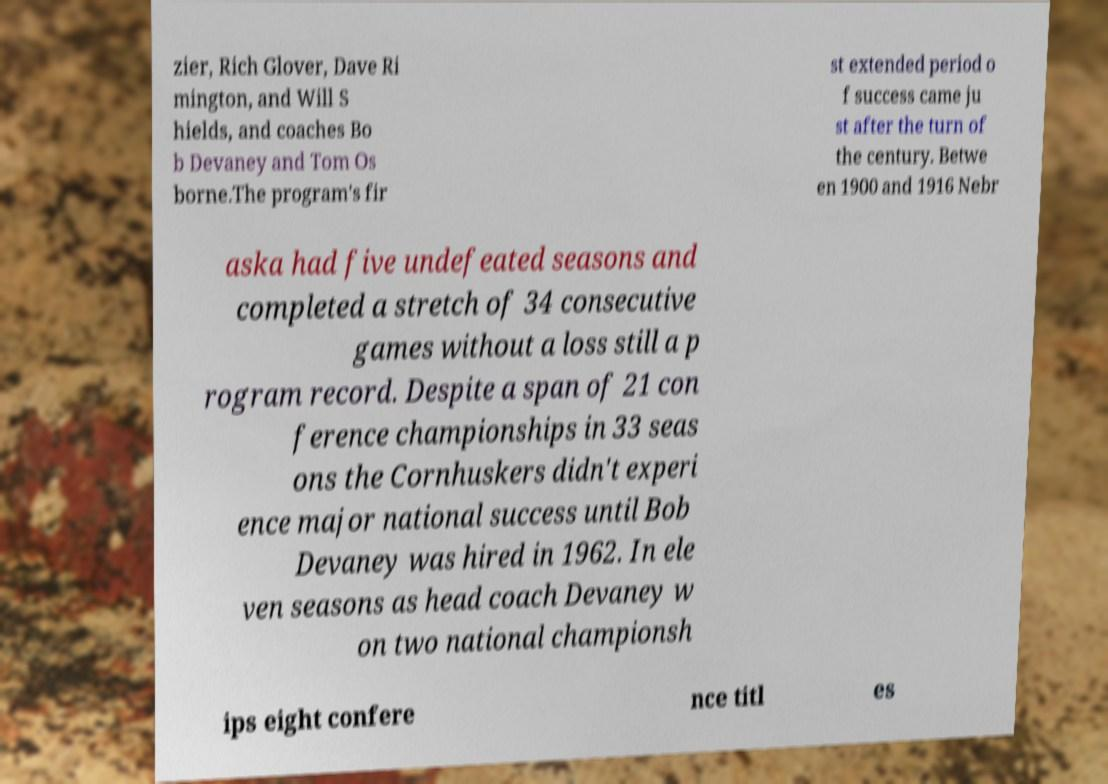Please read and relay the text visible in this image. What does it say? zier, Rich Glover, Dave Ri mington, and Will S hields, and coaches Bo b Devaney and Tom Os borne.The program's fir st extended period o f success came ju st after the turn of the century. Betwe en 1900 and 1916 Nebr aska had five undefeated seasons and completed a stretch of 34 consecutive games without a loss still a p rogram record. Despite a span of 21 con ference championships in 33 seas ons the Cornhuskers didn't experi ence major national success until Bob Devaney was hired in 1962. In ele ven seasons as head coach Devaney w on two national championsh ips eight confere nce titl es 